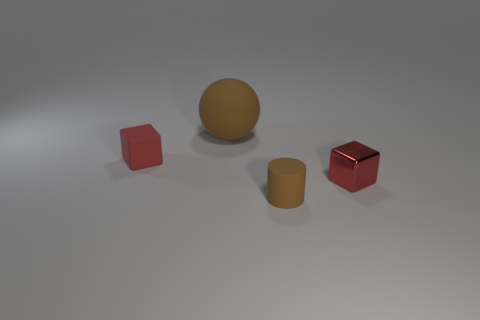Add 3 big brown rubber things. How many objects exist? 7 Subtract all cylinders. How many objects are left? 3 Add 2 brown metal things. How many brown metal things exist? 2 Subtract 0 purple cubes. How many objects are left? 4 Subtract all matte blocks. Subtract all tiny yellow things. How many objects are left? 3 Add 4 large matte balls. How many large matte balls are left? 5 